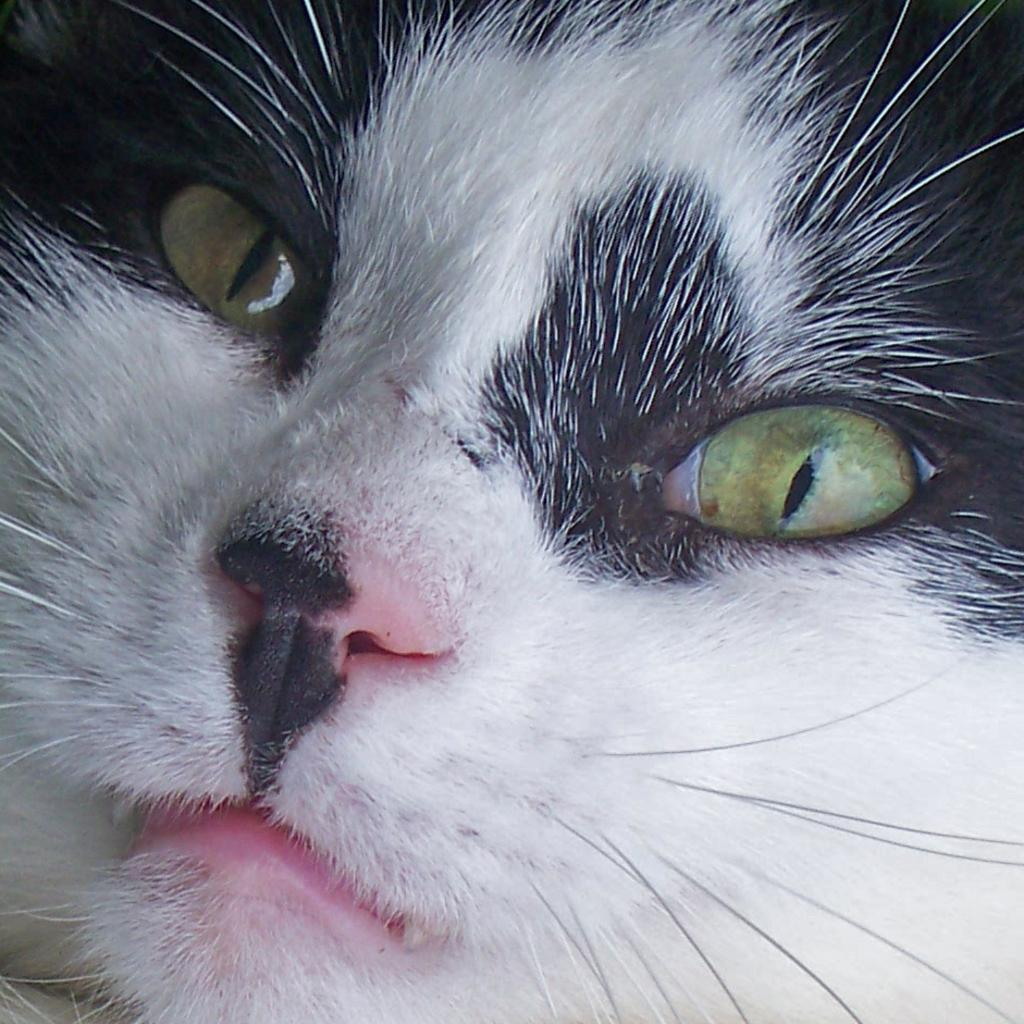What type of animal is in the picture? There is a cat in the picture. What type of bun can be seen teaching the cat in the image? There is no bun or teaching activity present in the image; it features a cat. 